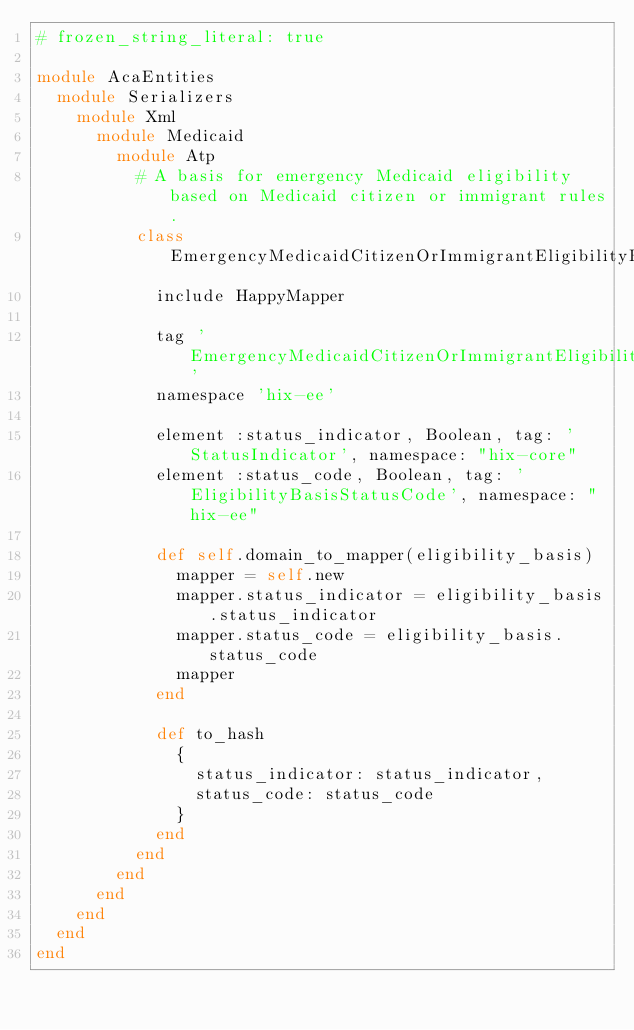Convert code to text. <code><loc_0><loc_0><loc_500><loc_500><_Ruby_># frozen_string_literal: true

module AcaEntities
  module Serializers
    module Xml
      module Medicaid
        module Atp
          # A basis for emergency Medicaid eligibility based on Medicaid citizen or immigrant rules.
          class EmergencyMedicaidCitizenOrImmigrantEligibilityBasis
            include HappyMapper

            tag 'EmergencyMedicaidCitizenOrImmigrantEligibilityBasis'
            namespace 'hix-ee'

            element :status_indicator, Boolean, tag: 'StatusIndicator', namespace: "hix-core"
            element :status_code, Boolean, tag: 'EligibilityBasisStatusCode', namespace: "hix-ee"

            def self.domain_to_mapper(eligibility_basis)
              mapper = self.new
              mapper.status_indicator = eligibility_basis.status_indicator
              mapper.status_code = eligibility_basis.status_code
              mapper
            end

            def to_hash
              {
                status_indicator: status_indicator,
                status_code: status_code
              }
            end
          end
        end
      end
    end
  end
end</code> 